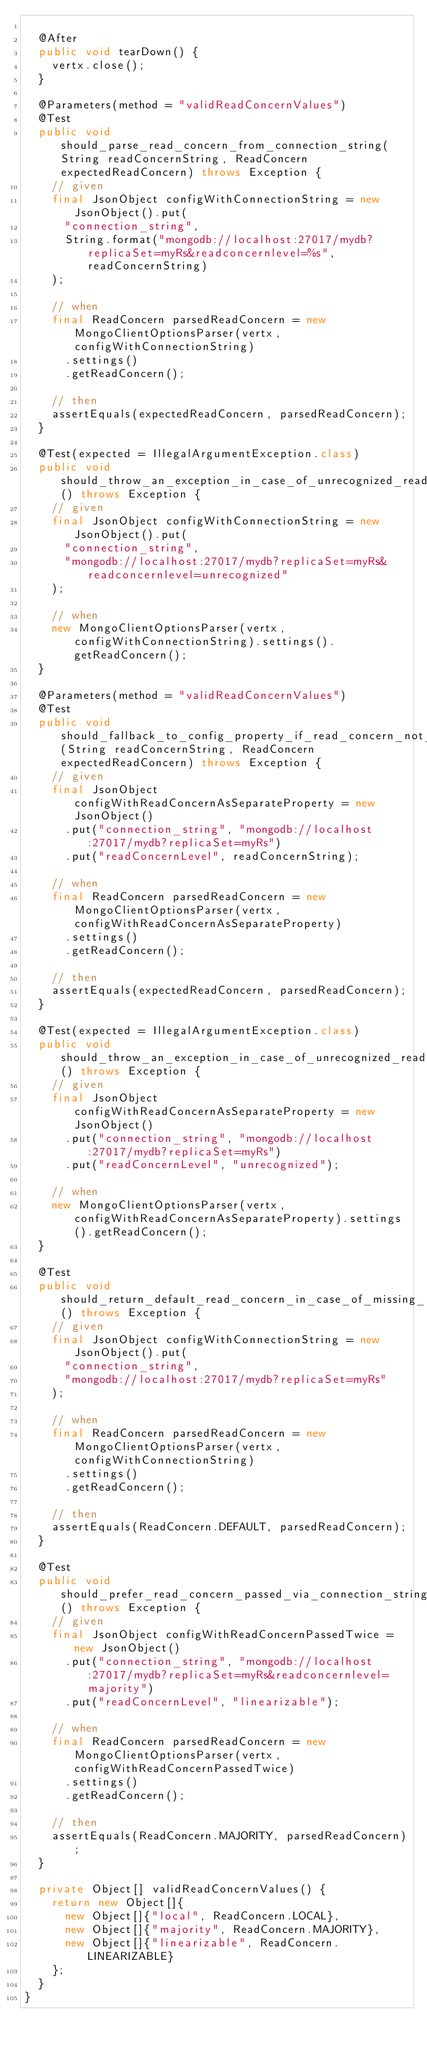<code> <loc_0><loc_0><loc_500><loc_500><_Java_>
  @After
  public void tearDown() {
    vertx.close();
  }

  @Parameters(method = "validReadConcernValues")
  @Test
  public void should_parse_read_concern_from_connection_string(String readConcernString, ReadConcern expectedReadConcern) throws Exception {
    // given
    final JsonObject configWithConnectionString = new JsonObject().put(
      "connection_string",
      String.format("mongodb://localhost:27017/mydb?replicaSet=myRs&readconcernlevel=%s", readConcernString)
    );

    // when
    final ReadConcern parsedReadConcern = new MongoClientOptionsParser(vertx, configWithConnectionString)
      .settings()
      .getReadConcern();

    // then
    assertEquals(expectedReadConcern, parsedReadConcern);
  }

  @Test(expected = IllegalArgumentException.class)
  public void should_throw_an_exception_in_case_of_unrecognized_read_concern_level_in_connection_string() throws Exception {
    // given
    final JsonObject configWithConnectionString = new JsonObject().put(
      "connection_string",
      "mongodb://localhost:27017/mydb?replicaSet=myRs&readconcernlevel=unrecognized"
    );

    // when
    new MongoClientOptionsParser(vertx, configWithConnectionString).settings().getReadConcern();
  }

  @Parameters(method = "validReadConcernValues")
  @Test
  public void should_fallback_to_config_property_if_read_concern_not_present_in_connection_string(String readConcernString, ReadConcern expectedReadConcern) throws Exception {
    // given
    final JsonObject configWithReadConcernAsSeparateProperty = new JsonObject()
      .put("connection_string", "mongodb://localhost:27017/mydb?replicaSet=myRs")
      .put("readConcernLevel", readConcernString);

    // when
    final ReadConcern parsedReadConcern = new MongoClientOptionsParser(vertx, configWithReadConcernAsSeparateProperty)
      .settings()
      .getReadConcern();

    // then
    assertEquals(expectedReadConcern, parsedReadConcern);
  }

  @Test(expected = IllegalArgumentException.class)
  public void should_throw_an_exception_in_case_of_unrecognized_read_concern_level_passed_as_config_property() throws Exception {
    // given
    final JsonObject configWithReadConcernAsSeparateProperty = new JsonObject()
      .put("connection_string", "mongodb://localhost:27017/mydb?replicaSet=myRs")
      .put("readConcernLevel", "unrecognized");

    // when
    new MongoClientOptionsParser(vertx, configWithReadConcernAsSeparateProperty).settings().getReadConcern();
  }

  @Test
  public void should_return_default_read_concern_in_case_of_missing_read_concern_in_connection_string_or_config_object() throws Exception {
    // given
    final JsonObject configWithConnectionString = new JsonObject().put(
      "connection_string",
      "mongodb://localhost:27017/mydb?replicaSet=myRs"
    );

    // when
    final ReadConcern parsedReadConcern = new MongoClientOptionsParser(vertx, configWithConnectionString)
      .settings()
      .getReadConcern();

    // then
    assertEquals(ReadConcern.DEFAULT, parsedReadConcern);
  }

  @Test
  public void should_prefer_read_concern_passed_via_connection_string_over_property_value() throws Exception {
    // given
    final JsonObject configWithReadConcernPassedTwice = new JsonObject()
      .put("connection_string", "mongodb://localhost:27017/mydb?replicaSet=myRs&readconcernlevel=majority")
      .put("readConcernLevel", "linearizable");

    // when
    final ReadConcern parsedReadConcern = new MongoClientOptionsParser(vertx, configWithReadConcernPassedTwice)
      .settings()
      .getReadConcern();

    // then
    assertEquals(ReadConcern.MAJORITY, parsedReadConcern);
  }

  private Object[] validReadConcernValues() {
    return new Object[]{
      new Object[]{"local", ReadConcern.LOCAL},
      new Object[]{"majority", ReadConcern.MAJORITY},
      new Object[]{"linearizable", ReadConcern.LINEARIZABLE}
    };
  }
}
</code> 